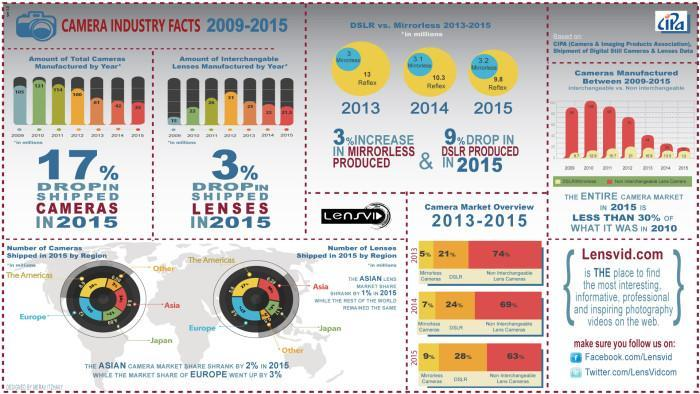What is the percentage drop in shipped lenses in 2015?
Answer the question with a short phrase. 3% What is the percentage drop in shipped cameras in 2015? 17% 